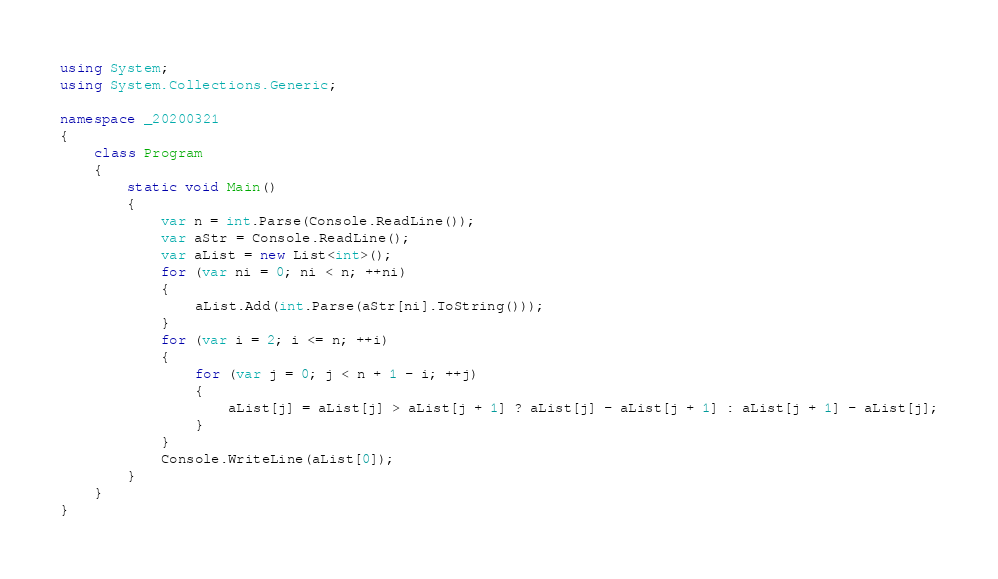<code> <loc_0><loc_0><loc_500><loc_500><_C#_>using System;
using System.Collections.Generic;

namespace _20200321
{
    class Program
    {
        static void Main()
        {
            var n = int.Parse(Console.ReadLine());
            var aStr = Console.ReadLine();
            var aList = new List<int>();
            for (var ni = 0; ni < n; ++ni)
            {
                aList.Add(int.Parse(aStr[ni].ToString()));
            }
            for (var i = 2; i <= n; ++i)
            {
                for (var j = 0; j < n + 1 - i; ++j)
                {
                    aList[j] = aList[j] > aList[j + 1] ? aList[j] - aList[j + 1] : aList[j + 1] - aList[j];
                }
            }
            Console.WriteLine(aList[0]);
        }
    }
}
</code> 